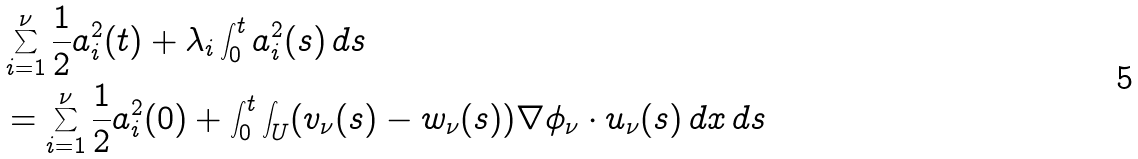Convert formula to latex. <formula><loc_0><loc_0><loc_500><loc_500>& \sum _ { i = 1 } ^ { \nu } \frac { 1 } { 2 } a _ { i } ^ { 2 } ( t ) + \lambda _ { i } \int _ { 0 } ^ { t } a ^ { 2 } _ { i } ( s ) \, d s \\ & = \sum _ { i = 1 } ^ { \nu } \frac { 1 } { 2 } a _ { i } ^ { 2 } ( 0 ) + \int _ { 0 } ^ { t } \int _ { U } ( v _ { \nu } ( s ) - w _ { \nu } ( s ) ) \nabla \phi _ { \nu } \cdot u _ { \nu } ( s ) \, d x \, d s</formula> 